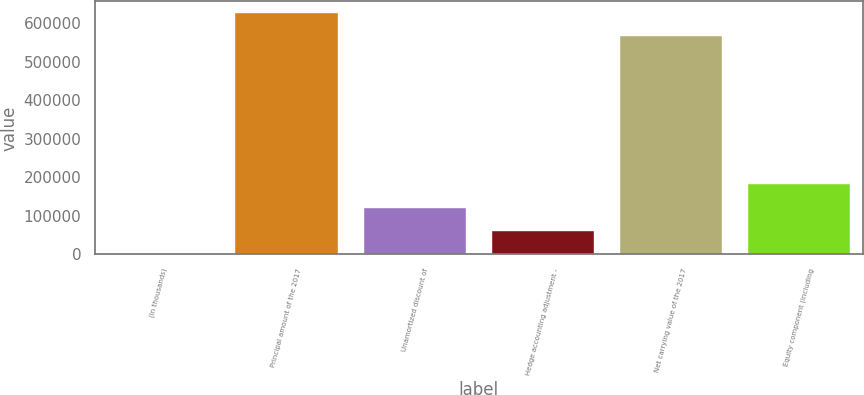Convert chart to OTSL. <chart><loc_0><loc_0><loc_500><loc_500><bar_chart><fcel>(In thousands)<fcel>Principal amount of the 2017<fcel>Unamortized discount of<fcel>Hedge accounting adjustment -<fcel>Net carrying value of the 2017<fcel>Equity component (including<nl><fcel>2014<fcel>624800<fcel>121611<fcel>61812.6<fcel>565001<fcel>181410<nl></chart> 